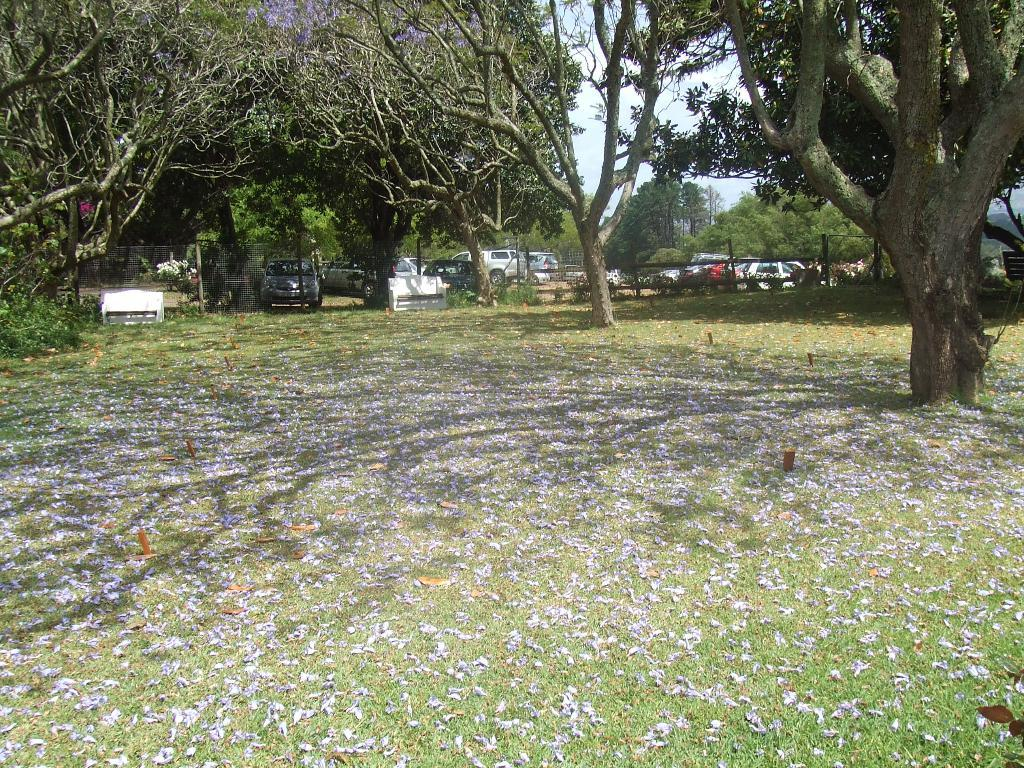What can be seen in the sky in the image? The sky with clouds is visible in the image. What type of natural elements are present in the image? There are trees in the image. What man-made objects can be seen in the image? Motor vehicles and a grill are present in the image. What type of seating is available in the image? Benches are visible in the image. What might be used for decoration or landscaping in the image? Shredded flowers are present in the image. What is visible on the ground in the image? The ground is visible in the image. Where is the scarecrow standing in the image? There is no scarecrow present in the image. What type of bird can be seen interacting with the chicken in the image? There is no chicken present in the image. 